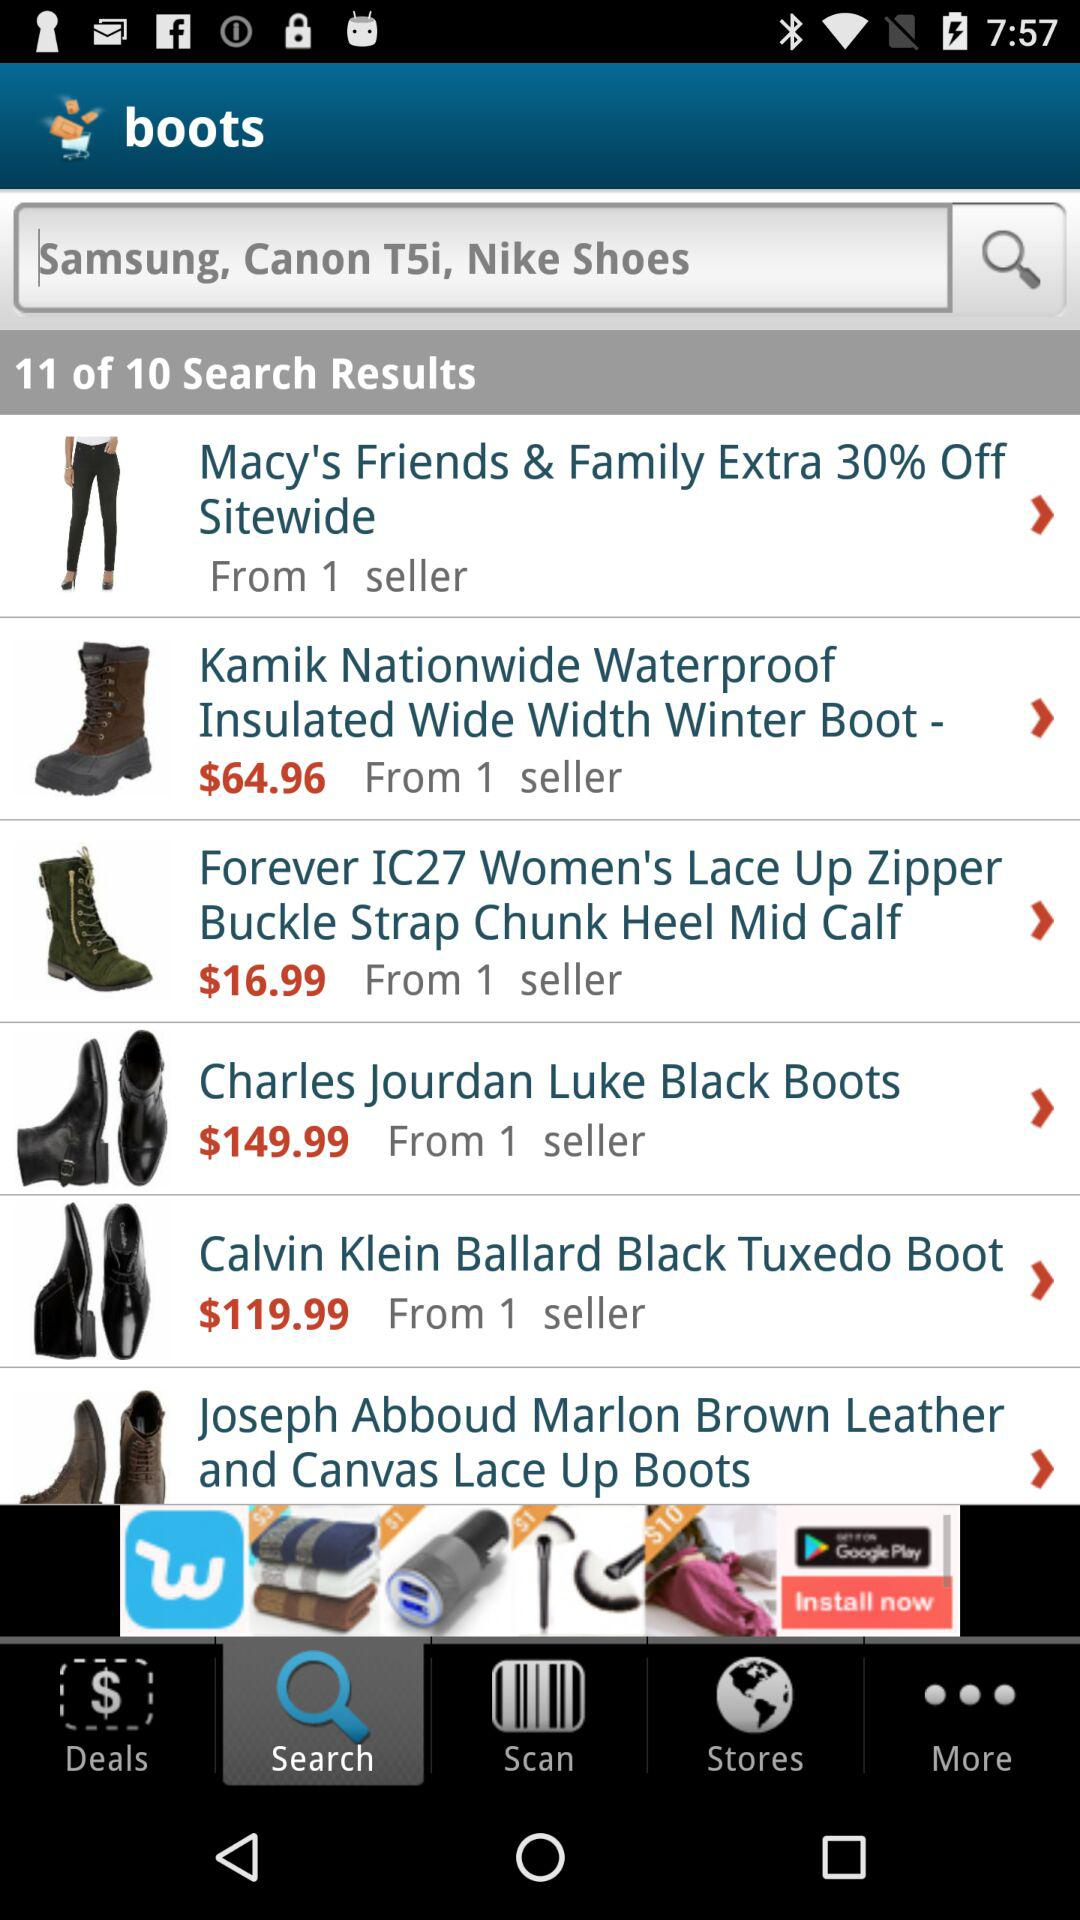Which is the selected tab? The selected tab is "Search". 